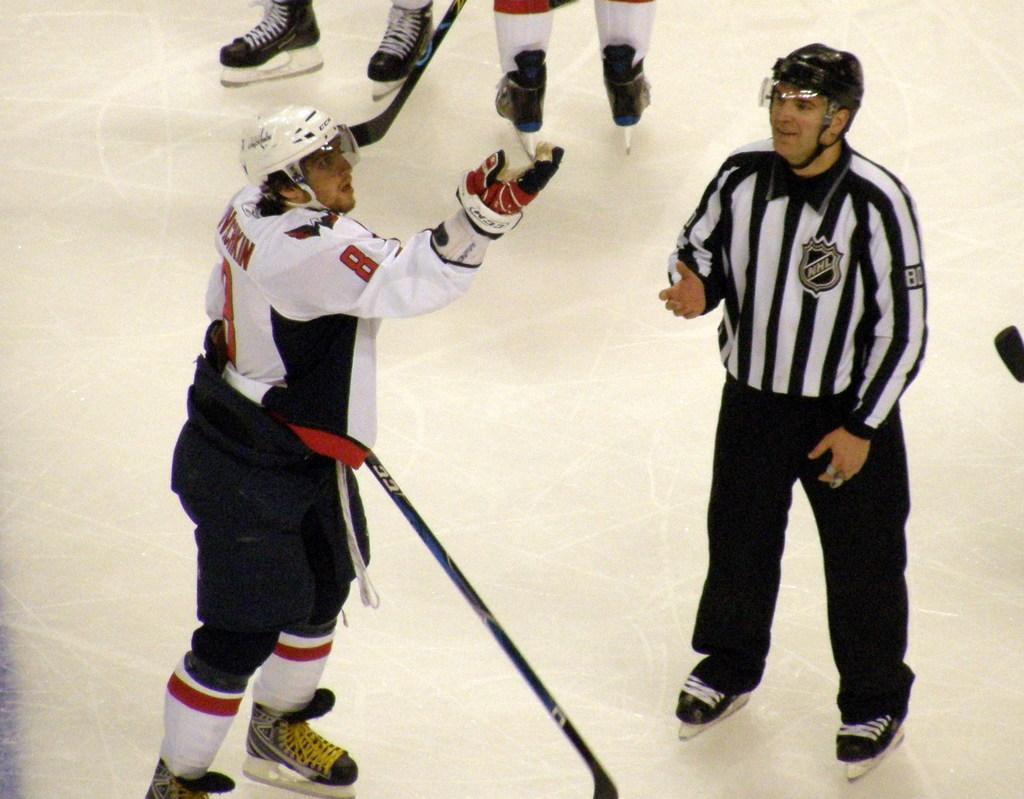Please provide a concise description of this image. There are two men skating on the ground and behind these to men,the legs of other two people are visible. 